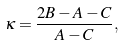Convert formula to latex. <formula><loc_0><loc_0><loc_500><loc_500>\kappa = \frac { 2 B - A - C } { A - C } ,</formula> 